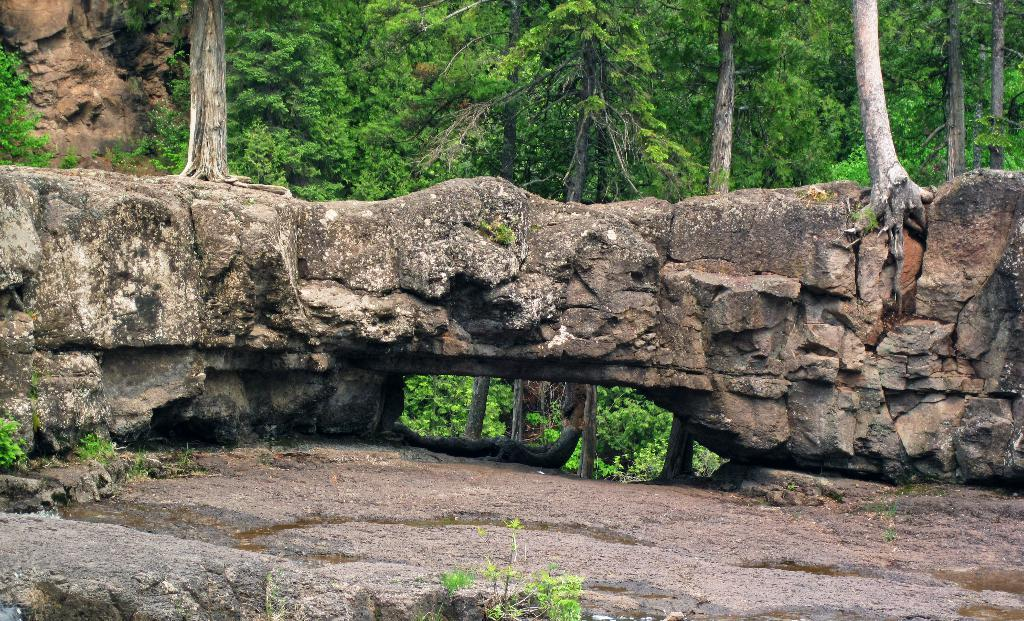What type of structure is located at the bottom of the image? There is a stone construction at the bottom of the image. What can be seen at the top of the image? There are trees and a rock at the top of the image. What type of vegetation is present in the foreground of the image? There are plants in the foreground of the image. How many balls are visible in the image? There are no balls present in the image. Is there a swing in the image? There is no swing present in the image. 